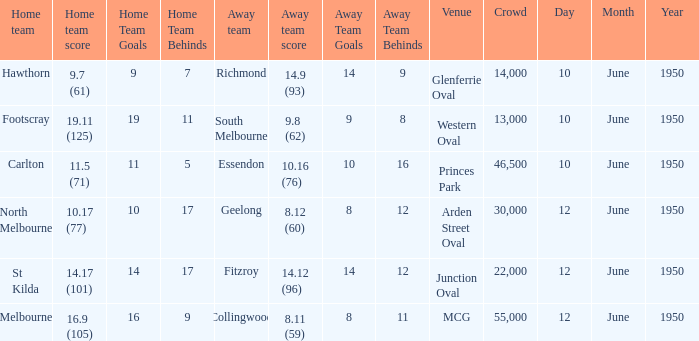What was the crowd when Melbourne was the home team? 55000.0. 